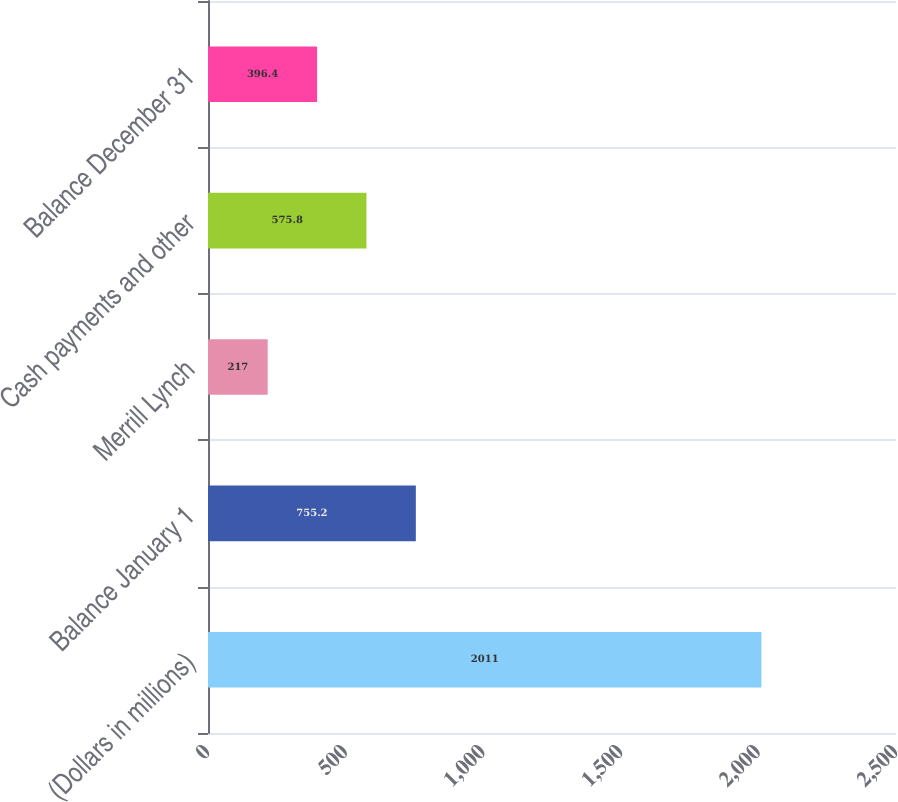<chart> <loc_0><loc_0><loc_500><loc_500><bar_chart><fcel>(Dollars in millions)<fcel>Balance January 1<fcel>Merrill Lynch<fcel>Cash payments and other<fcel>Balance December 31<nl><fcel>2011<fcel>755.2<fcel>217<fcel>575.8<fcel>396.4<nl></chart> 